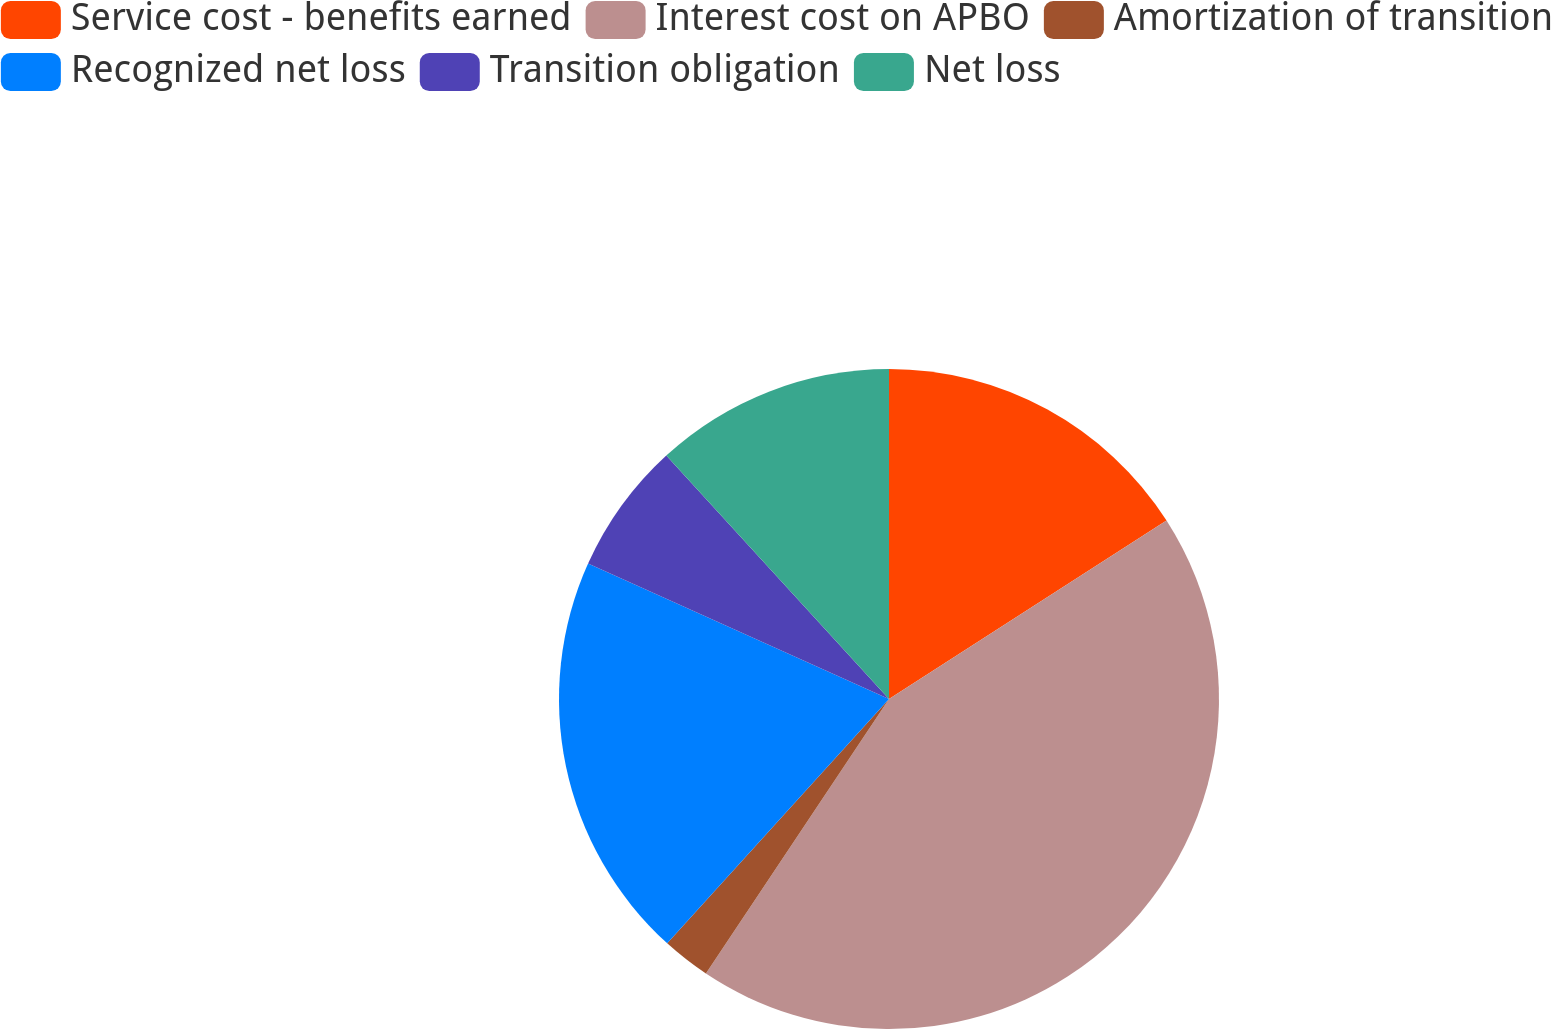Convert chart. <chart><loc_0><loc_0><loc_500><loc_500><pie_chart><fcel>Service cost - benefits earned<fcel>Interest cost on APBO<fcel>Amortization of transition<fcel>Recognized net loss<fcel>Transition obligation<fcel>Net loss<nl><fcel>15.9%<fcel>43.46%<fcel>2.37%<fcel>20.0%<fcel>6.48%<fcel>11.79%<nl></chart> 